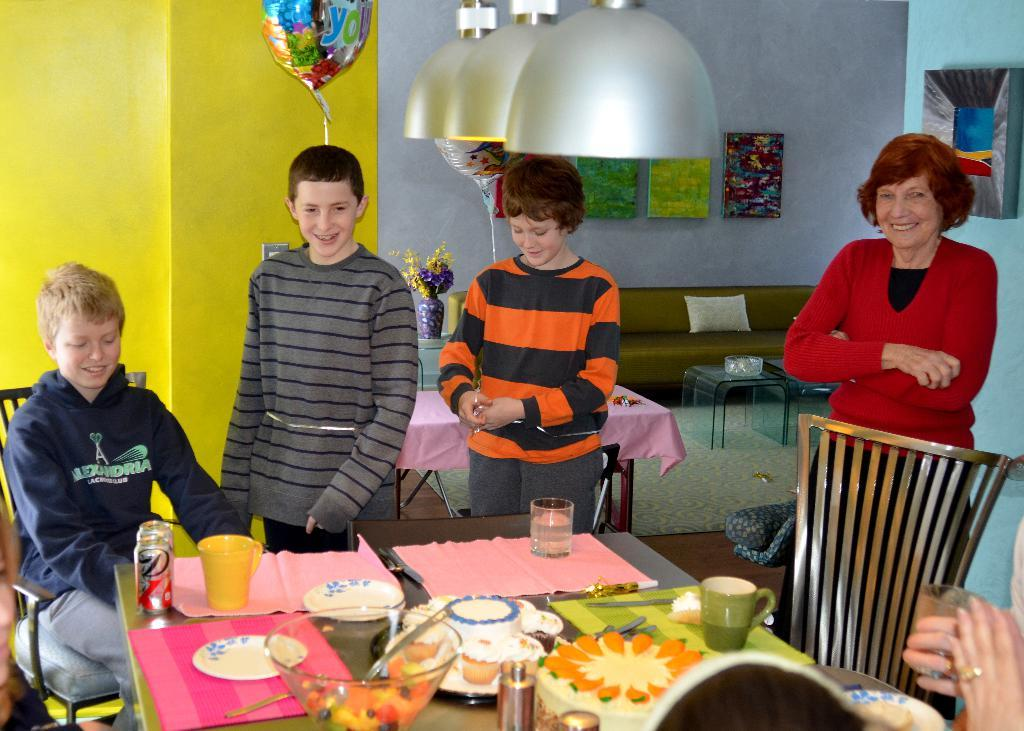What is the primary activity of the people in the image? The people in the image are standing, which suggests they might be waiting or conversing. What is the man in the image doing? The man is sitting on a chair in the image. What is on the table in the image? There is a bowl containing a salad, a glass, a plate, and a spoon on the table. What might the people in the image be using the glass for? The glass on the table might be used for drinking. What type of bead is hanging from the man's neck in the image? There is no bead hanging from the man's neck in the image. What does the smell of the salad in the bowl indicate about the image? The image does not convey any smells, so it is not possible to determine what the smell of the salad might indicate. 